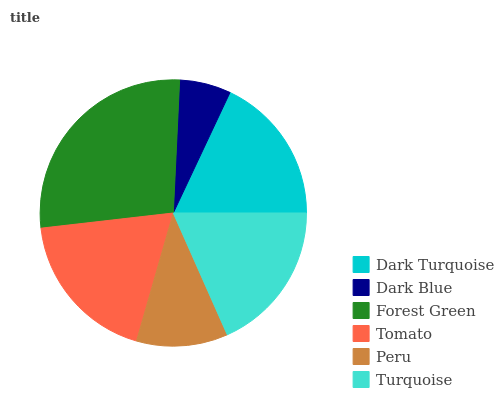Is Dark Blue the minimum?
Answer yes or no. Yes. Is Forest Green the maximum?
Answer yes or no. Yes. Is Forest Green the minimum?
Answer yes or no. No. Is Dark Blue the maximum?
Answer yes or no. No. Is Forest Green greater than Dark Blue?
Answer yes or no. Yes. Is Dark Blue less than Forest Green?
Answer yes or no. Yes. Is Dark Blue greater than Forest Green?
Answer yes or no. No. Is Forest Green less than Dark Blue?
Answer yes or no. No. Is Turquoise the high median?
Answer yes or no. Yes. Is Dark Turquoise the low median?
Answer yes or no. Yes. Is Tomato the high median?
Answer yes or no. No. Is Tomato the low median?
Answer yes or no. No. 